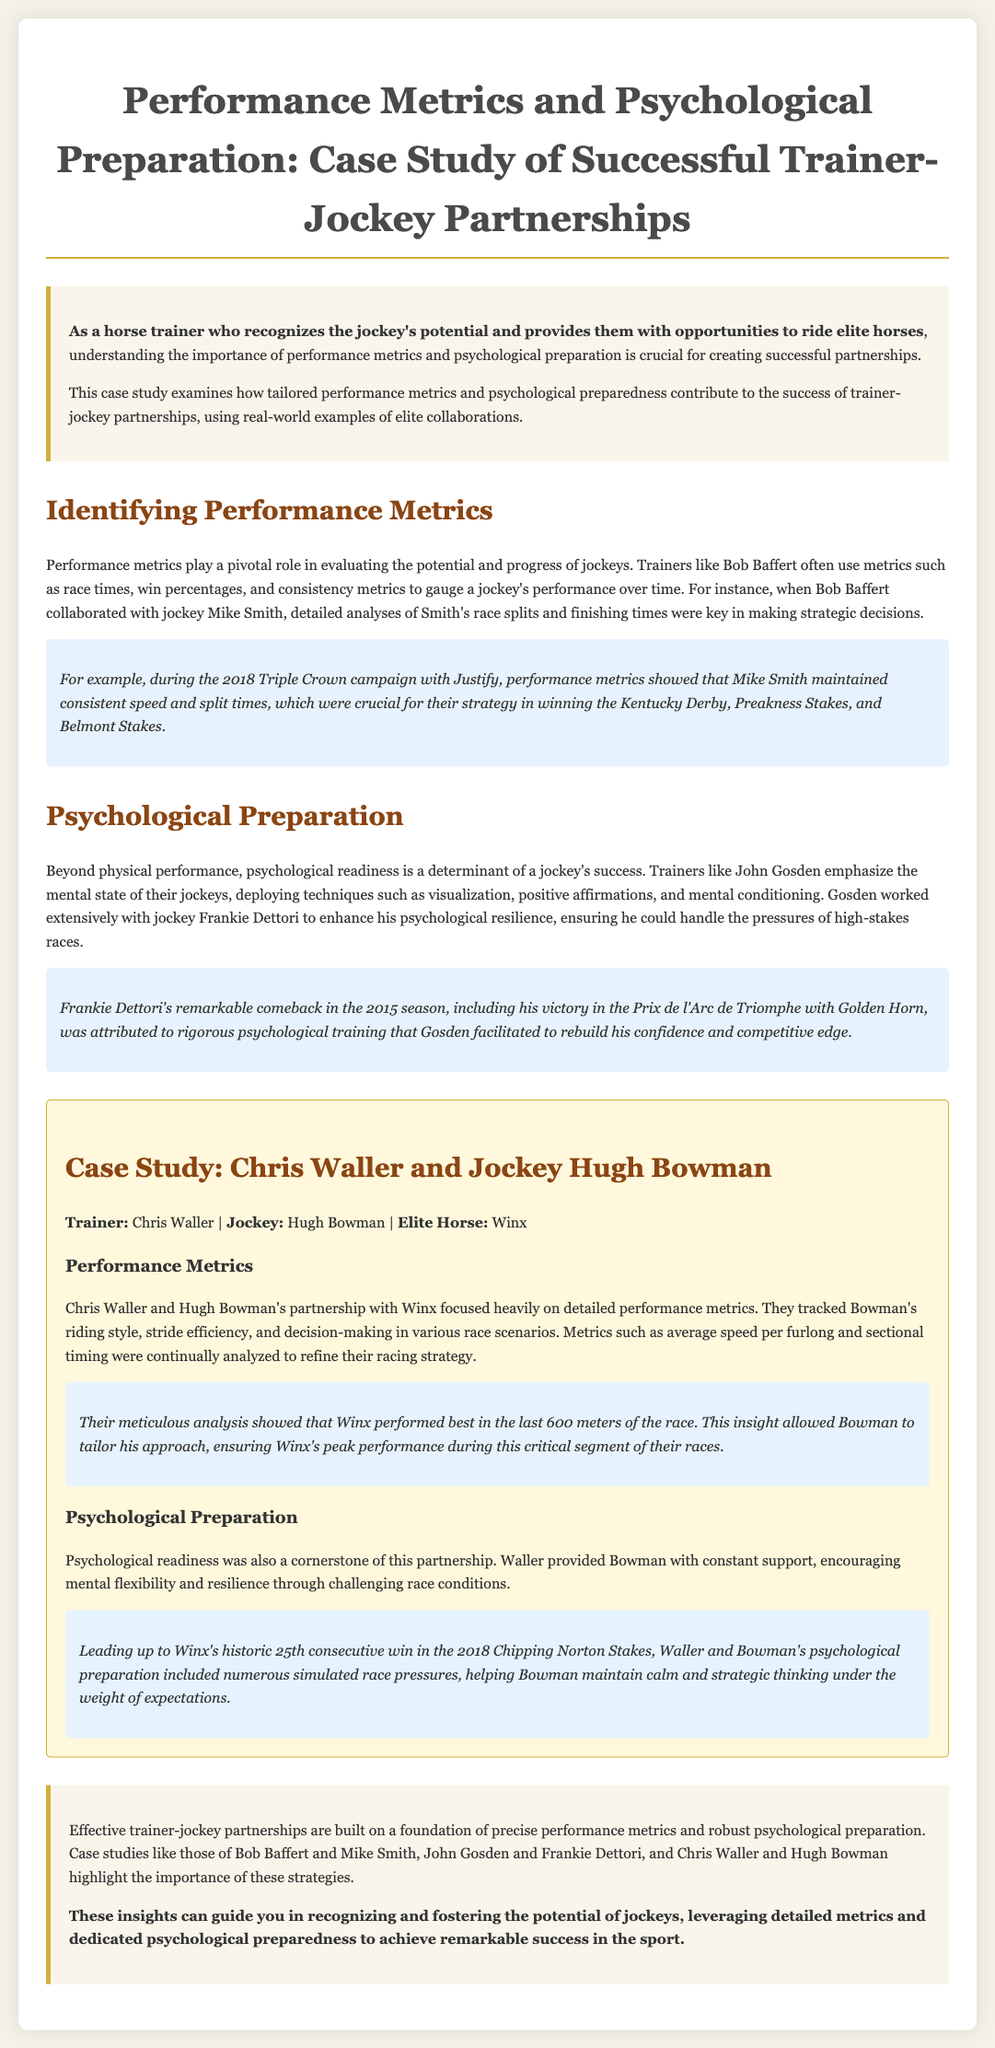what is the title of the case study? The title is displayed prominently at the top of the document, summarizing the subject matter.
Answer: Performance Metrics and Psychological Preparation: Case Study of Successful Trainer-Jockey Partnerships who collaborated with Bob Baffert to analyze race metrics? The document mentions a specific jockey who partnered with Baffert for performance analysis.
Answer: Mike Smith what horse did Frankie Dettori ride to victory in the 2015 season? The case study provides an example of a notable race during the 2015 season involving Dettori and a specific horse.
Answer: Golden Horn what specific performance metric is highlighted in Chris Waller and Hugh Bowman's partnership? The document refers to a key performance metric used to evaluate Bowman's riding style.
Answer: average speed per furlong how many consecutive wins did Winx achieve before the 2018 Chipping Norton Stakes? The document describes a historical milestone achieved by Winx prior to a specific race.
Answer: 25 what psychological technique was emphasized by John Gosden? The case study provides insight into mental conditioning techniques used by trainers for psychological preparation.
Answer: visualization which race marked Mike Smith's strategic performance metrics success? The document illustrates a particular set of races where specific performance metrics were essential for success.
Answer: Kentucky Derby, Preakness Stakes, and Belmont Stakes who is the trainer associated with the 2015 season comeback of a famous jockey? The document names a trainer who worked closely with a jockey during a successful period.
Answer: John Gosden what was a key personal trait encouraged by Chris Waller for Hugh Bowman? The text discusses the importance of a particular mental state in the partnership between Waller and Bowman.
Answer: mental flexibility 